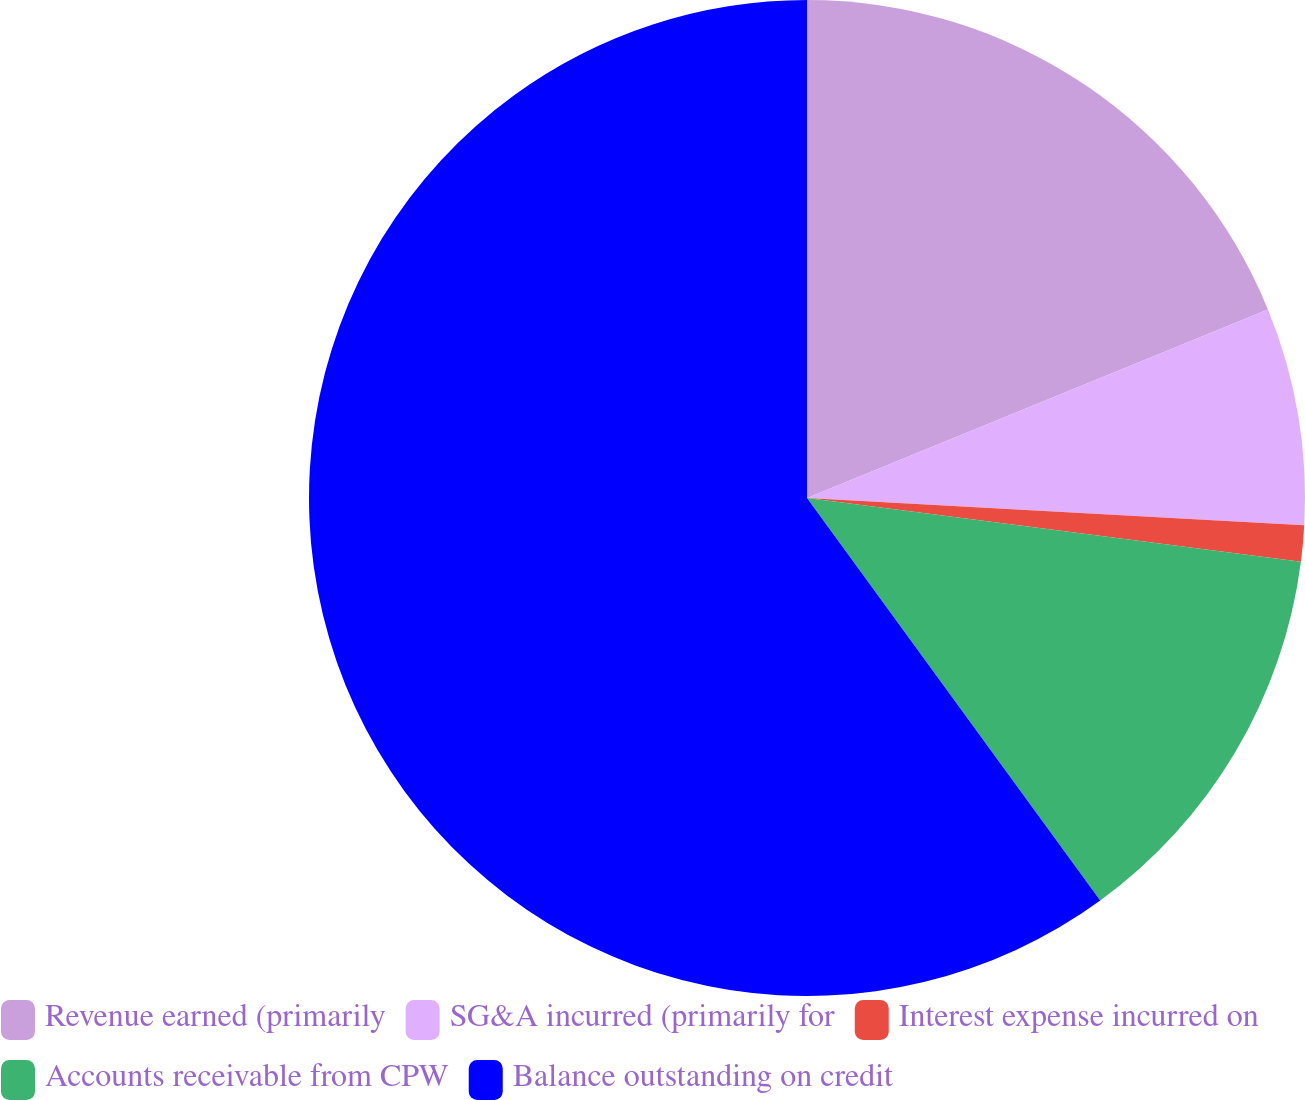<chart> <loc_0><loc_0><loc_500><loc_500><pie_chart><fcel>Revenue earned (primarily<fcel>SG&A incurred (primarily for<fcel>Interest expense incurred on<fcel>Accounts receivable from CPW<fcel>Balance outstanding on credit<nl><fcel>18.82%<fcel>7.05%<fcel>1.17%<fcel>12.94%<fcel>60.02%<nl></chart> 